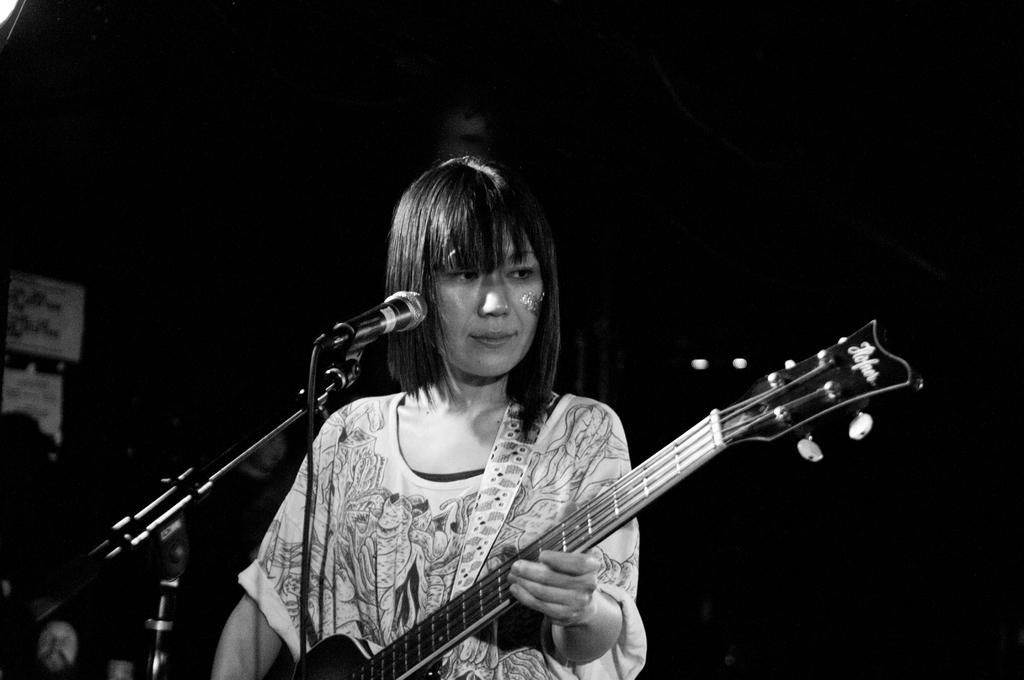Who is the main subject in the image? There is a woman in the image. What is the woman holding in the image? The woman is holding a guitar. What other object is present near the woman? There is a mic with a stand beside the woman. What type of chair is the woman sitting on in the image? There is no chair present in the image; the woman is standing. What role does the root play in the image? There is no root present in the image. 